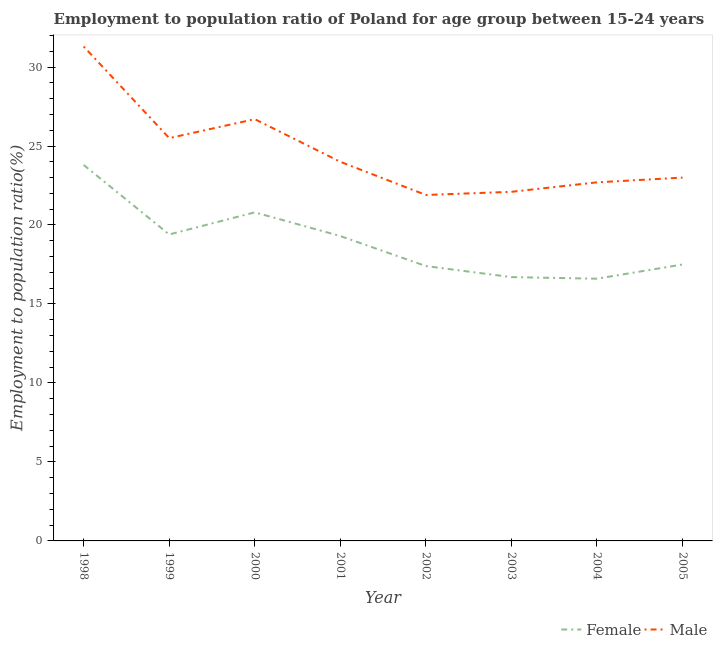Is the number of lines equal to the number of legend labels?
Your answer should be very brief. Yes. What is the employment to population ratio(female) in 2004?
Provide a short and direct response. 16.6. Across all years, what is the maximum employment to population ratio(female)?
Your answer should be compact. 23.8. Across all years, what is the minimum employment to population ratio(female)?
Make the answer very short. 16.6. In which year was the employment to population ratio(female) minimum?
Your answer should be very brief. 2004. What is the total employment to population ratio(male) in the graph?
Offer a terse response. 197.2. What is the difference between the employment to population ratio(female) in 1999 and that in 2005?
Provide a succinct answer. 1.9. What is the difference between the employment to population ratio(female) in 2002 and the employment to population ratio(male) in 1999?
Give a very brief answer. -8.1. What is the average employment to population ratio(male) per year?
Provide a succinct answer. 24.65. In the year 1999, what is the difference between the employment to population ratio(female) and employment to population ratio(male)?
Your answer should be very brief. -6.1. In how many years, is the employment to population ratio(male) greater than 20 %?
Provide a succinct answer. 8. What is the ratio of the employment to population ratio(male) in 1999 to that in 2004?
Your answer should be very brief. 1.12. Is the difference between the employment to population ratio(male) in 2001 and 2003 greater than the difference between the employment to population ratio(female) in 2001 and 2003?
Your answer should be compact. No. What is the difference between the highest and the second highest employment to population ratio(male)?
Your answer should be very brief. 4.6. What is the difference between the highest and the lowest employment to population ratio(male)?
Provide a short and direct response. 9.4. Is the sum of the employment to population ratio(male) in 2004 and 2005 greater than the maximum employment to population ratio(female) across all years?
Provide a succinct answer. Yes. Is the employment to population ratio(male) strictly greater than the employment to population ratio(female) over the years?
Your answer should be compact. Yes. How many years are there in the graph?
Keep it short and to the point. 8. What is the difference between two consecutive major ticks on the Y-axis?
Keep it short and to the point. 5. Are the values on the major ticks of Y-axis written in scientific E-notation?
Make the answer very short. No. How are the legend labels stacked?
Your answer should be compact. Horizontal. What is the title of the graph?
Ensure brevity in your answer.  Employment to population ratio of Poland for age group between 15-24 years. Does "Long-term debt" appear as one of the legend labels in the graph?
Make the answer very short. No. What is the label or title of the X-axis?
Keep it short and to the point. Year. What is the label or title of the Y-axis?
Your answer should be very brief. Employment to population ratio(%). What is the Employment to population ratio(%) in Female in 1998?
Offer a very short reply. 23.8. What is the Employment to population ratio(%) in Male in 1998?
Provide a short and direct response. 31.3. What is the Employment to population ratio(%) in Female in 1999?
Your answer should be compact. 19.4. What is the Employment to population ratio(%) of Male in 1999?
Offer a terse response. 25.5. What is the Employment to population ratio(%) of Female in 2000?
Provide a short and direct response. 20.8. What is the Employment to population ratio(%) of Male in 2000?
Keep it short and to the point. 26.7. What is the Employment to population ratio(%) in Female in 2001?
Offer a very short reply. 19.3. What is the Employment to population ratio(%) in Female in 2002?
Your response must be concise. 17.4. What is the Employment to population ratio(%) in Male in 2002?
Offer a terse response. 21.9. What is the Employment to population ratio(%) in Female in 2003?
Your answer should be very brief. 16.7. What is the Employment to population ratio(%) of Male in 2003?
Give a very brief answer. 22.1. What is the Employment to population ratio(%) of Female in 2004?
Provide a succinct answer. 16.6. What is the Employment to population ratio(%) of Male in 2004?
Give a very brief answer. 22.7. What is the Employment to population ratio(%) of Male in 2005?
Your answer should be very brief. 23. Across all years, what is the maximum Employment to population ratio(%) in Female?
Your answer should be very brief. 23.8. Across all years, what is the maximum Employment to population ratio(%) of Male?
Your response must be concise. 31.3. Across all years, what is the minimum Employment to population ratio(%) in Female?
Give a very brief answer. 16.6. Across all years, what is the minimum Employment to population ratio(%) of Male?
Provide a short and direct response. 21.9. What is the total Employment to population ratio(%) of Female in the graph?
Offer a very short reply. 151.5. What is the total Employment to population ratio(%) in Male in the graph?
Provide a short and direct response. 197.2. What is the difference between the Employment to population ratio(%) in Female in 1998 and that in 2000?
Your response must be concise. 3. What is the difference between the Employment to population ratio(%) in Male in 1998 and that in 2000?
Ensure brevity in your answer.  4.6. What is the difference between the Employment to population ratio(%) of Female in 1998 and that in 2001?
Your answer should be very brief. 4.5. What is the difference between the Employment to population ratio(%) of Female in 1998 and that in 2003?
Give a very brief answer. 7.1. What is the difference between the Employment to population ratio(%) in Female in 1998 and that in 2005?
Provide a short and direct response. 6.3. What is the difference between the Employment to population ratio(%) of Female in 1999 and that in 2001?
Make the answer very short. 0.1. What is the difference between the Employment to population ratio(%) of Male in 1999 and that in 2001?
Make the answer very short. 1.5. What is the difference between the Employment to population ratio(%) of Female in 1999 and that in 2002?
Keep it short and to the point. 2. What is the difference between the Employment to population ratio(%) of Male in 1999 and that in 2003?
Offer a very short reply. 3.4. What is the difference between the Employment to population ratio(%) in Female in 1999 and that in 2004?
Your answer should be compact. 2.8. What is the difference between the Employment to population ratio(%) of Male in 1999 and that in 2004?
Your response must be concise. 2.8. What is the difference between the Employment to population ratio(%) in Female in 1999 and that in 2005?
Provide a succinct answer. 1.9. What is the difference between the Employment to population ratio(%) in Female in 2000 and that in 2002?
Keep it short and to the point. 3.4. What is the difference between the Employment to population ratio(%) of Female in 2000 and that in 2004?
Your response must be concise. 4.2. What is the difference between the Employment to population ratio(%) of Male in 2000 and that in 2004?
Offer a very short reply. 4. What is the difference between the Employment to population ratio(%) of Male in 2000 and that in 2005?
Offer a terse response. 3.7. What is the difference between the Employment to population ratio(%) in Male in 2001 and that in 2002?
Provide a succinct answer. 2.1. What is the difference between the Employment to population ratio(%) of Female in 2001 and that in 2003?
Offer a very short reply. 2.6. What is the difference between the Employment to population ratio(%) in Male in 2001 and that in 2004?
Give a very brief answer. 1.3. What is the difference between the Employment to population ratio(%) of Male in 2001 and that in 2005?
Give a very brief answer. 1. What is the difference between the Employment to population ratio(%) of Male in 2002 and that in 2003?
Your response must be concise. -0.2. What is the difference between the Employment to population ratio(%) of Female in 2002 and that in 2005?
Provide a short and direct response. -0.1. What is the difference between the Employment to population ratio(%) in Male in 2002 and that in 2005?
Your answer should be compact. -1.1. What is the difference between the Employment to population ratio(%) in Female in 2003 and that in 2004?
Your answer should be very brief. 0.1. What is the difference between the Employment to population ratio(%) of Male in 2003 and that in 2004?
Your answer should be very brief. -0.6. What is the difference between the Employment to population ratio(%) in Female in 2003 and that in 2005?
Your answer should be compact. -0.8. What is the difference between the Employment to population ratio(%) in Male in 2004 and that in 2005?
Offer a terse response. -0.3. What is the difference between the Employment to population ratio(%) in Female in 1998 and the Employment to population ratio(%) in Male in 2000?
Keep it short and to the point. -2.9. What is the difference between the Employment to population ratio(%) of Female in 1998 and the Employment to population ratio(%) of Male in 2003?
Offer a terse response. 1.7. What is the difference between the Employment to population ratio(%) in Female in 1998 and the Employment to population ratio(%) in Male in 2004?
Your answer should be compact. 1.1. What is the difference between the Employment to population ratio(%) in Female in 1999 and the Employment to population ratio(%) in Male in 2005?
Provide a succinct answer. -3.6. What is the difference between the Employment to population ratio(%) in Female in 2000 and the Employment to population ratio(%) in Male in 2004?
Keep it short and to the point. -1.9. What is the difference between the Employment to population ratio(%) in Female in 2001 and the Employment to population ratio(%) in Male in 2002?
Ensure brevity in your answer.  -2.6. What is the difference between the Employment to population ratio(%) of Female in 2001 and the Employment to population ratio(%) of Male in 2003?
Your answer should be very brief. -2.8. What is the difference between the Employment to population ratio(%) in Female in 2001 and the Employment to population ratio(%) in Male in 2005?
Your answer should be compact. -3.7. What is the difference between the Employment to population ratio(%) in Female in 2002 and the Employment to population ratio(%) in Male in 2003?
Give a very brief answer. -4.7. What is the difference between the Employment to population ratio(%) in Female in 2002 and the Employment to population ratio(%) in Male in 2004?
Ensure brevity in your answer.  -5.3. What is the difference between the Employment to population ratio(%) of Female in 2002 and the Employment to population ratio(%) of Male in 2005?
Provide a short and direct response. -5.6. What is the difference between the Employment to population ratio(%) of Female in 2003 and the Employment to population ratio(%) of Male in 2005?
Give a very brief answer. -6.3. What is the average Employment to population ratio(%) in Female per year?
Provide a succinct answer. 18.94. What is the average Employment to population ratio(%) of Male per year?
Offer a terse response. 24.65. In the year 1999, what is the difference between the Employment to population ratio(%) of Female and Employment to population ratio(%) of Male?
Offer a terse response. -6.1. In the year 2000, what is the difference between the Employment to population ratio(%) in Female and Employment to population ratio(%) in Male?
Your answer should be very brief. -5.9. In the year 2004, what is the difference between the Employment to population ratio(%) of Female and Employment to population ratio(%) of Male?
Offer a very short reply. -6.1. In the year 2005, what is the difference between the Employment to population ratio(%) in Female and Employment to population ratio(%) in Male?
Your answer should be very brief. -5.5. What is the ratio of the Employment to population ratio(%) in Female in 1998 to that in 1999?
Your answer should be compact. 1.23. What is the ratio of the Employment to population ratio(%) in Male in 1998 to that in 1999?
Offer a very short reply. 1.23. What is the ratio of the Employment to population ratio(%) of Female in 1998 to that in 2000?
Offer a terse response. 1.14. What is the ratio of the Employment to population ratio(%) of Male in 1998 to that in 2000?
Your answer should be compact. 1.17. What is the ratio of the Employment to population ratio(%) of Female in 1998 to that in 2001?
Your response must be concise. 1.23. What is the ratio of the Employment to population ratio(%) of Male in 1998 to that in 2001?
Make the answer very short. 1.3. What is the ratio of the Employment to population ratio(%) in Female in 1998 to that in 2002?
Your answer should be compact. 1.37. What is the ratio of the Employment to population ratio(%) in Male in 1998 to that in 2002?
Make the answer very short. 1.43. What is the ratio of the Employment to population ratio(%) in Female in 1998 to that in 2003?
Give a very brief answer. 1.43. What is the ratio of the Employment to population ratio(%) in Male in 1998 to that in 2003?
Your response must be concise. 1.42. What is the ratio of the Employment to population ratio(%) of Female in 1998 to that in 2004?
Make the answer very short. 1.43. What is the ratio of the Employment to population ratio(%) of Male in 1998 to that in 2004?
Give a very brief answer. 1.38. What is the ratio of the Employment to population ratio(%) of Female in 1998 to that in 2005?
Provide a succinct answer. 1.36. What is the ratio of the Employment to population ratio(%) in Male in 1998 to that in 2005?
Provide a short and direct response. 1.36. What is the ratio of the Employment to population ratio(%) of Female in 1999 to that in 2000?
Give a very brief answer. 0.93. What is the ratio of the Employment to population ratio(%) of Male in 1999 to that in 2000?
Ensure brevity in your answer.  0.96. What is the ratio of the Employment to population ratio(%) of Female in 1999 to that in 2001?
Your answer should be very brief. 1.01. What is the ratio of the Employment to population ratio(%) in Male in 1999 to that in 2001?
Your response must be concise. 1.06. What is the ratio of the Employment to population ratio(%) in Female in 1999 to that in 2002?
Keep it short and to the point. 1.11. What is the ratio of the Employment to population ratio(%) of Male in 1999 to that in 2002?
Give a very brief answer. 1.16. What is the ratio of the Employment to population ratio(%) of Female in 1999 to that in 2003?
Your answer should be compact. 1.16. What is the ratio of the Employment to population ratio(%) in Male in 1999 to that in 2003?
Your answer should be compact. 1.15. What is the ratio of the Employment to population ratio(%) of Female in 1999 to that in 2004?
Offer a terse response. 1.17. What is the ratio of the Employment to population ratio(%) in Male in 1999 to that in 2004?
Provide a short and direct response. 1.12. What is the ratio of the Employment to population ratio(%) of Female in 1999 to that in 2005?
Your response must be concise. 1.11. What is the ratio of the Employment to population ratio(%) of Male in 1999 to that in 2005?
Offer a very short reply. 1.11. What is the ratio of the Employment to population ratio(%) of Female in 2000 to that in 2001?
Provide a short and direct response. 1.08. What is the ratio of the Employment to population ratio(%) in Male in 2000 to that in 2001?
Offer a terse response. 1.11. What is the ratio of the Employment to population ratio(%) of Female in 2000 to that in 2002?
Keep it short and to the point. 1.2. What is the ratio of the Employment to population ratio(%) of Male in 2000 to that in 2002?
Your answer should be compact. 1.22. What is the ratio of the Employment to population ratio(%) in Female in 2000 to that in 2003?
Your answer should be very brief. 1.25. What is the ratio of the Employment to population ratio(%) in Male in 2000 to that in 2003?
Ensure brevity in your answer.  1.21. What is the ratio of the Employment to population ratio(%) in Female in 2000 to that in 2004?
Make the answer very short. 1.25. What is the ratio of the Employment to population ratio(%) of Male in 2000 to that in 2004?
Your answer should be compact. 1.18. What is the ratio of the Employment to population ratio(%) in Female in 2000 to that in 2005?
Offer a very short reply. 1.19. What is the ratio of the Employment to population ratio(%) in Male in 2000 to that in 2005?
Your response must be concise. 1.16. What is the ratio of the Employment to population ratio(%) of Female in 2001 to that in 2002?
Provide a succinct answer. 1.11. What is the ratio of the Employment to population ratio(%) in Male in 2001 to that in 2002?
Give a very brief answer. 1.1. What is the ratio of the Employment to population ratio(%) of Female in 2001 to that in 2003?
Your response must be concise. 1.16. What is the ratio of the Employment to population ratio(%) in Male in 2001 to that in 2003?
Keep it short and to the point. 1.09. What is the ratio of the Employment to population ratio(%) of Female in 2001 to that in 2004?
Offer a very short reply. 1.16. What is the ratio of the Employment to population ratio(%) in Male in 2001 to that in 2004?
Your answer should be very brief. 1.06. What is the ratio of the Employment to population ratio(%) of Female in 2001 to that in 2005?
Provide a short and direct response. 1.1. What is the ratio of the Employment to population ratio(%) of Male in 2001 to that in 2005?
Keep it short and to the point. 1.04. What is the ratio of the Employment to population ratio(%) in Female in 2002 to that in 2003?
Ensure brevity in your answer.  1.04. What is the ratio of the Employment to population ratio(%) of Male in 2002 to that in 2003?
Make the answer very short. 0.99. What is the ratio of the Employment to population ratio(%) of Female in 2002 to that in 2004?
Keep it short and to the point. 1.05. What is the ratio of the Employment to population ratio(%) in Male in 2002 to that in 2004?
Your answer should be compact. 0.96. What is the ratio of the Employment to population ratio(%) of Male in 2002 to that in 2005?
Offer a very short reply. 0.95. What is the ratio of the Employment to population ratio(%) in Female in 2003 to that in 2004?
Your answer should be very brief. 1.01. What is the ratio of the Employment to population ratio(%) of Male in 2003 to that in 2004?
Your answer should be compact. 0.97. What is the ratio of the Employment to population ratio(%) of Female in 2003 to that in 2005?
Make the answer very short. 0.95. What is the ratio of the Employment to population ratio(%) in Male in 2003 to that in 2005?
Offer a very short reply. 0.96. What is the ratio of the Employment to population ratio(%) of Female in 2004 to that in 2005?
Make the answer very short. 0.95. What is the difference between the highest and the lowest Employment to population ratio(%) in Female?
Your answer should be compact. 7.2. 